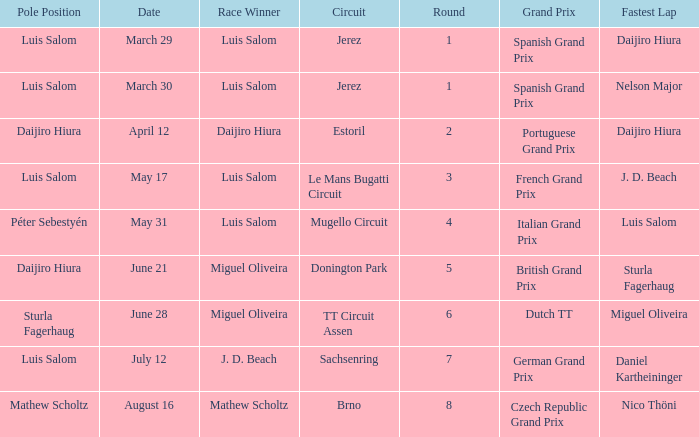What grand prixs did Daijiro Hiura win?  Portuguese Grand Prix. 